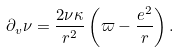<formula> <loc_0><loc_0><loc_500><loc_500>\partial _ { v } \nu = \frac { 2 \nu \kappa } { r ^ { 2 } } \left ( \varpi - \frac { e ^ { 2 } } { r } \right ) .</formula> 